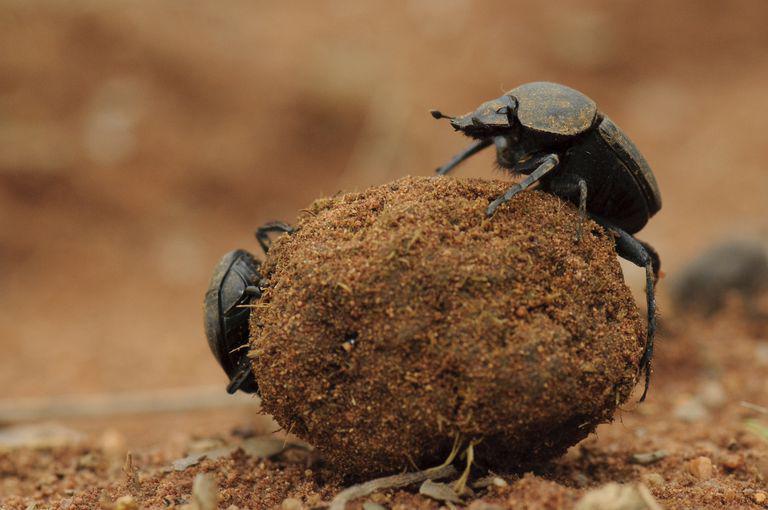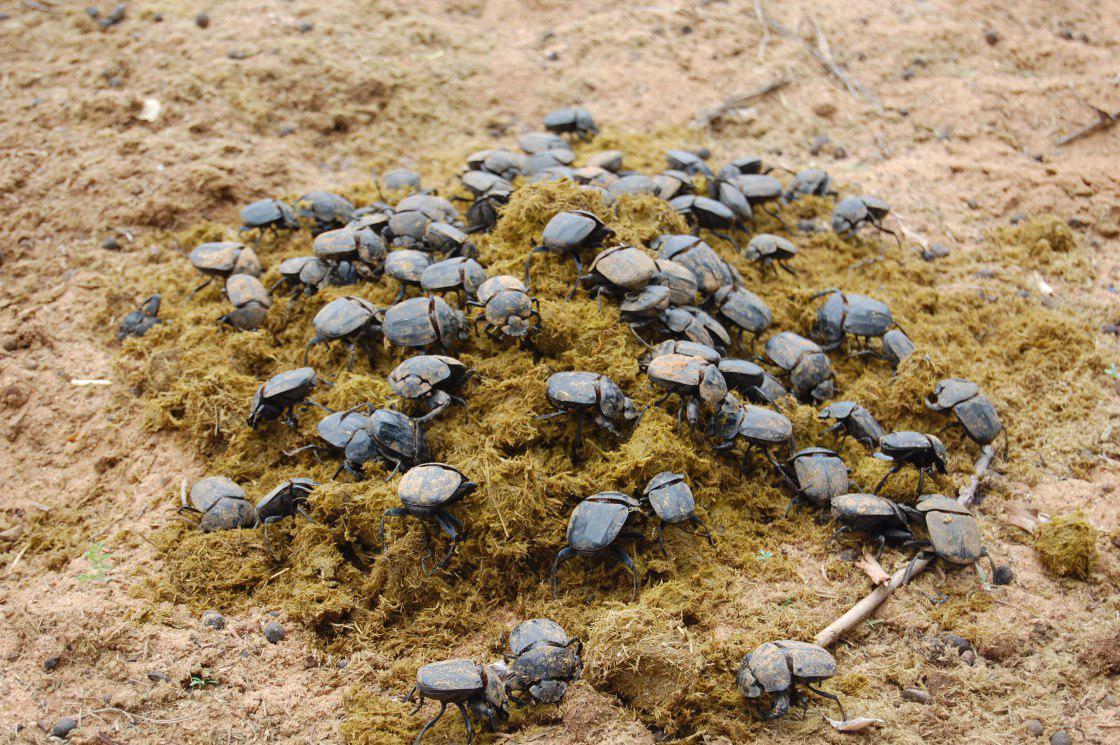The first image is the image on the left, the second image is the image on the right. For the images displayed, is the sentence "Each image shows exactly one beetle." factually correct? Answer yes or no. No. 